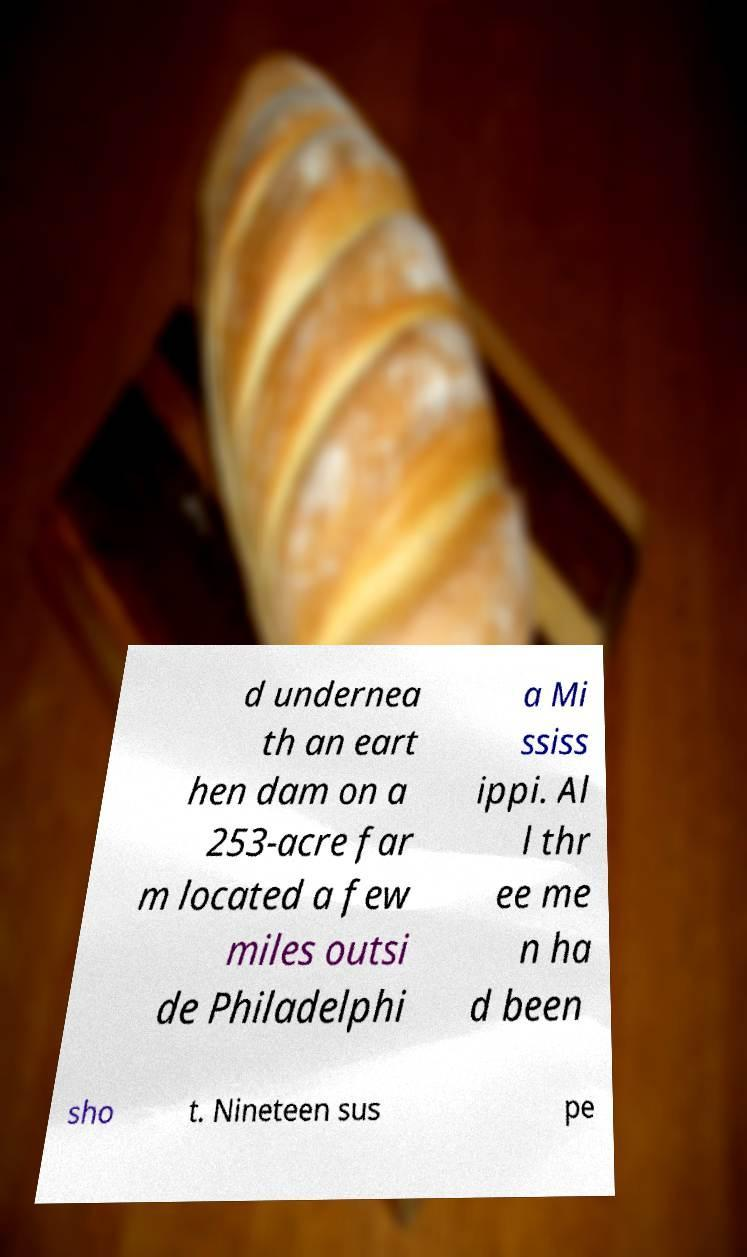There's text embedded in this image that I need extracted. Can you transcribe it verbatim? d undernea th an eart hen dam on a 253-acre far m located a few miles outsi de Philadelphi a Mi ssiss ippi. Al l thr ee me n ha d been sho t. Nineteen sus pe 